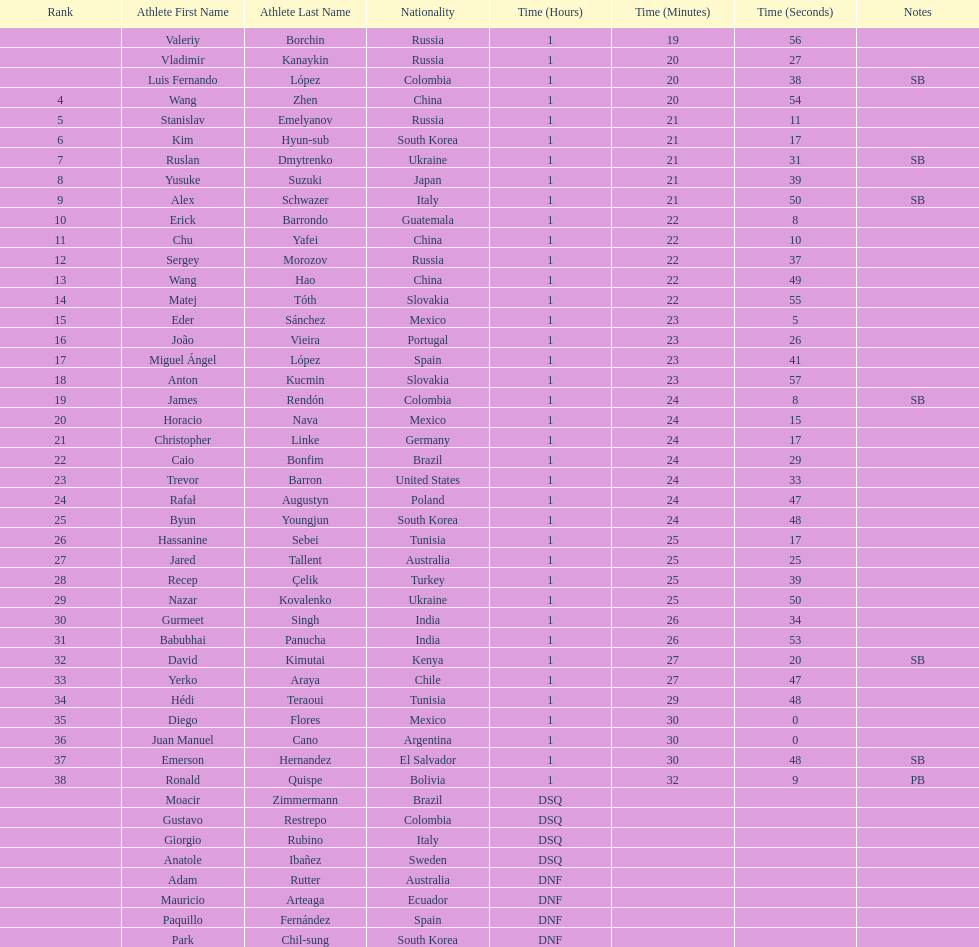Which chinese athlete had the fastest time? Wang Zhen. 